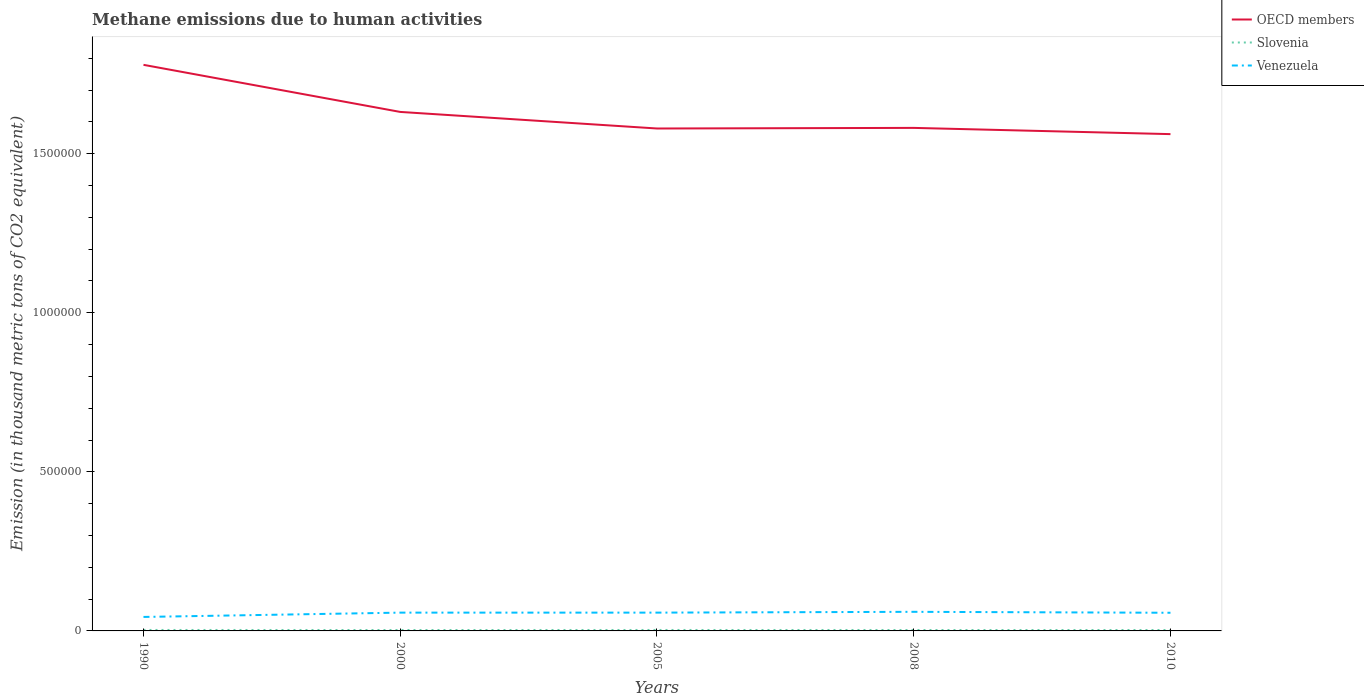Across all years, what is the maximum amount of methane emitted in Venezuela?
Provide a succinct answer. 4.39e+04. In which year was the amount of methane emitted in OECD members maximum?
Your answer should be compact. 2010. What is the total amount of methane emitted in OECD members in the graph?
Give a very brief answer. 1.77e+04. What is the difference between the highest and the second highest amount of methane emitted in OECD members?
Offer a very short reply. 2.18e+05. What is the difference between the highest and the lowest amount of methane emitted in OECD members?
Ensure brevity in your answer.  2. Is the amount of methane emitted in Slovenia strictly greater than the amount of methane emitted in OECD members over the years?
Offer a terse response. Yes. How many years are there in the graph?
Offer a terse response. 5. Are the values on the major ticks of Y-axis written in scientific E-notation?
Provide a short and direct response. No. Does the graph contain any zero values?
Give a very brief answer. No. Does the graph contain grids?
Your response must be concise. No. How many legend labels are there?
Provide a succinct answer. 3. What is the title of the graph?
Provide a succinct answer. Methane emissions due to human activities. Does "Least developed countries" appear as one of the legend labels in the graph?
Provide a short and direct response. No. What is the label or title of the Y-axis?
Ensure brevity in your answer.  Emission (in thousand metric tons of CO2 equivalent). What is the Emission (in thousand metric tons of CO2 equivalent) of OECD members in 1990?
Make the answer very short. 1.78e+06. What is the Emission (in thousand metric tons of CO2 equivalent) in Slovenia in 1990?
Keep it short and to the point. 3033.9. What is the Emission (in thousand metric tons of CO2 equivalent) in Venezuela in 1990?
Make the answer very short. 4.39e+04. What is the Emission (in thousand metric tons of CO2 equivalent) of OECD members in 2000?
Give a very brief answer. 1.63e+06. What is the Emission (in thousand metric tons of CO2 equivalent) in Slovenia in 2000?
Your answer should be very brief. 2871.1. What is the Emission (in thousand metric tons of CO2 equivalent) in Venezuela in 2000?
Provide a succinct answer. 5.75e+04. What is the Emission (in thousand metric tons of CO2 equivalent) of OECD members in 2005?
Offer a terse response. 1.58e+06. What is the Emission (in thousand metric tons of CO2 equivalent) of Slovenia in 2005?
Your answer should be compact. 2979.9. What is the Emission (in thousand metric tons of CO2 equivalent) of Venezuela in 2005?
Give a very brief answer. 5.75e+04. What is the Emission (in thousand metric tons of CO2 equivalent) in OECD members in 2008?
Make the answer very short. 1.58e+06. What is the Emission (in thousand metric tons of CO2 equivalent) in Slovenia in 2008?
Your response must be concise. 2912.5. What is the Emission (in thousand metric tons of CO2 equivalent) in Venezuela in 2008?
Your answer should be compact. 6.00e+04. What is the Emission (in thousand metric tons of CO2 equivalent) in OECD members in 2010?
Offer a terse response. 1.56e+06. What is the Emission (in thousand metric tons of CO2 equivalent) of Slovenia in 2010?
Your answer should be very brief. 2901.7. What is the Emission (in thousand metric tons of CO2 equivalent) of Venezuela in 2010?
Make the answer very short. 5.71e+04. Across all years, what is the maximum Emission (in thousand metric tons of CO2 equivalent) of OECD members?
Provide a short and direct response. 1.78e+06. Across all years, what is the maximum Emission (in thousand metric tons of CO2 equivalent) in Slovenia?
Provide a short and direct response. 3033.9. Across all years, what is the maximum Emission (in thousand metric tons of CO2 equivalent) of Venezuela?
Give a very brief answer. 6.00e+04. Across all years, what is the minimum Emission (in thousand metric tons of CO2 equivalent) of OECD members?
Offer a terse response. 1.56e+06. Across all years, what is the minimum Emission (in thousand metric tons of CO2 equivalent) in Slovenia?
Your response must be concise. 2871.1. Across all years, what is the minimum Emission (in thousand metric tons of CO2 equivalent) in Venezuela?
Keep it short and to the point. 4.39e+04. What is the total Emission (in thousand metric tons of CO2 equivalent) of OECD members in the graph?
Offer a very short reply. 8.13e+06. What is the total Emission (in thousand metric tons of CO2 equivalent) in Slovenia in the graph?
Give a very brief answer. 1.47e+04. What is the total Emission (in thousand metric tons of CO2 equivalent) in Venezuela in the graph?
Provide a short and direct response. 2.76e+05. What is the difference between the Emission (in thousand metric tons of CO2 equivalent) in OECD members in 1990 and that in 2000?
Your response must be concise. 1.48e+05. What is the difference between the Emission (in thousand metric tons of CO2 equivalent) of Slovenia in 1990 and that in 2000?
Offer a terse response. 162.8. What is the difference between the Emission (in thousand metric tons of CO2 equivalent) in Venezuela in 1990 and that in 2000?
Offer a terse response. -1.36e+04. What is the difference between the Emission (in thousand metric tons of CO2 equivalent) of OECD members in 1990 and that in 2005?
Provide a short and direct response. 2.00e+05. What is the difference between the Emission (in thousand metric tons of CO2 equivalent) in Slovenia in 1990 and that in 2005?
Provide a short and direct response. 54. What is the difference between the Emission (in thousand metric tons of CO2 equivalent) in Venezuela in 1990 and that in 2005?
Give a very brief answer. -1.36e+04. What is the difference between the Emission (in thousand metric tons of CO2 equivalent) in OECD members in 1990 and that in 2008?
Your answer should be compact. 1.98e+05. What is the difference between the Emission (in thousand metric tons of CO2 equivalent) in Slovenia in 1990 and that in 2008?
Provide a short and direct response. 121.4. What is the difference between the Emission (in thousand metric tons of CO2 equivalent) in Venezuela in 1990 and that in 2008?
Provide a short and direct response. -1.61e+04. What is the difference between the Emission (in thousand metric tons of CO2 equivalent) of OECD members in 1990 and that in 2010?
Offer a terse response. 2.18e+05. What is the difference between the Emission (in thousand metric tons of CO2 equivalent) in Slovenia in 1990 and that in 2010?
Provide a succinct answer. 132.2. What is the difference between the Emission (in thousand metric tons of CO2 equivalent) in Venezuela in 1990 and that in 2010?
Ensure brevity in your answer.  -1.31e+04. What is the difference between the Emission (in thousand metric tons of CO2 equivalent) in OECD members in 2000 and that in 2005?
Make the answer very short. 5.21e+04. What is the difference between the Emission (in thousand metric tons of CO2 equivalent) in Slovenia in 2000 and that in 2005?
Offer a very short reply. -108.8. What is the difference between the Emission (in thousand metric tons of CO2 equivalent) of OECD members in 2000 and that in 2008?
Offer a terse response. 5.02e+04. What is the difference between the Emission (in thousand metric tons of CO2 equivalent) in Slovenia in 2000 and that in 2008?
Keep it short and to the point. -41.4. What is the difference between the Emission (in thousand metric tons of CO2 equivalent) of Venezuela in 2000 and that in 2008?
Keep it short and to the point. -2550.4. What is the difference between the Emission (in thousand metric tons of CO2 equivalent) of OECD members in 2000 and that in 2010?
Provide a short and direct response. 6.98e+04. What is the difference between the Emission (in thousand metric tons of CO2 equivalent) of Slovenia in 2000 and that in 2010?
Your answer should be very brief. -30.6. What is the difference between the Emission (in thousand metric tons of CO2 equivalent) in Venezuela in 2000 and that in 2010?
Offer a very short reply. 425.9. What is the difference between the Emission (in thousand metric tons of CO2 equivalent) of OECD members in 2005 and that in 2008?
Your response must be concise. -1871.6. What is the difference between the Emission (in thousand metric tons of CO2 equivalent) in Slovenia in 2005 and that in 2008?
Keep it short and to the point. 67.4. What is the difference between the Emission (in thousand metric tons of CO2 equivalent) in Venezuela in 2005 and that in 2008?
Offer a terse response. -2551.2. What is the difference between the Emission (in thousand metric tons of CO2 equivalent) of OECD members in 2005 and that in 2010?
Your response must be concise. 1.77e+04. What is the difference between the Emission (in thousand metric tons of CO2 equivalent) of Slovenia in 2005 and that in 2010?
Offer a very short reply. 78.2. What is the difference between the Emission (in thousand metric tons of CO2 equivalent) of Venezuela in 2005 and that in 2010?
Make the answer very short. 425.1. What is the difference between the Emission (in thousand metric tons of CO2 equivalent) of OECD members in 2008 and that in 2010?
Provide a succinct answer. 1.96e+04. What is the difference between the Emission (in thousand metric tons of CO2 equivalent) of Venezuela in 2008 and that in 2010?
Provide a short and direct response. 2976.3. What is the difference between the Emission (in thousand metric tons of CO2 equivalent) in OECD members in 1990 and the Emission (in thousand metric tons of CO2 equivalent) in Slovenia in 2000?
Give a very brief answer. 1.78e+06. What is the difference between the Emission (in thousand metric tons of CO2 equivalent) of OECD members in 1990 and the Emission (in thousand metric tons of CO2 equivalent) of Venezuela in 2000?
Provide a succinct answer. 1.72e+06. What is the difference between the Emission (in thousand metric tons of CO2 equivalent) of Slovenia in 1990 and the Emission (in thousand metric tons of CO2 equivalent) of Venezuela in 2000?
Ensure brevity in your answer.  -5.45e+04. What is the difference between the Emission (in thousand metric tons of CO2 equivalent) in OECD members in 1990 and the Emission (in thousand metric tons of CO2 equivalent) in Slovenia in 2005?
Make the answer very short. 1.78e+06. What is the difference between the Emission (in thousand metric tons of CO2 equivalent) of OECD members in 1990 and the Emission (in thousand metric tons of CO2 equivalent) of Venezuela in 2005?
Your response must be concise. 1.72e+06. What is the difference between the Emission (in thousand metric tons of CO2 equivalent) in Slovenia in 1990 and the Emission (in thousand metric tons of CO2 equivalent) in Venezuela in 2005?
Provide a short and direct response. -5.45e+04. What is the difference between the Emission (in thousand metric tons of CO2 equivalent) of OECD members in 1990 and the Emission (in thousand metric tons of CO2 equivalent) of Slovenia in 2008?
Provide a succinct answer. 1.78e+06. What is the difference between the Emission (in thousand metric tons of CO2 equivalent) of OECD members in 1990 and the Emission (in thousand metric tons of CO2 equivalent) of Venezuela in 2008?
Your answer should be very brief. 1.72e+06. What is the difference between the Emission (in thousand metric tons of CO2 equivalent) of Slovenia in 1990 and the Emission (in thousand metric tons of CO2 equivalent) of Venezuela in 2008?
Your answer should be very brief. -5.70e+04. What is the difference between the Emission (in thousand metric tons of CO2 equivalent) of OECD members in 1990 and the Emission (in thousand metric tons of CO2 equivalent) of Slovenia in 2010?
Offer a terse response. 1.78e+06. What is the difference between the Emission (in thousand metric tons of CO2 equivalent) of OECD members in 1990 and the Emission (in thousand metric tons of CO2 equivalent) of Venezuela in 2010?
Provide a succinct answer. 1.72e+06. What is the difference between the Emission (in thousand metric tons of CO2 equivalent) in Slovenia in 1990 and the Emission (in thousand metric tons of CO2 equivalent) in Venezuela in 2010?
Your answer should be very brief. -5.40e+04. What is the difference between the Emission (in thousand metric tons of CO2 equivalent) of OECD members in 2000 and the Emission (in thousand metric tons of CO2 equivalent) of Slovenia in 2005?
Make the answer very short. 1.63e+06. What is the difference between the Emission (in thousand metric tons of CO2 equivalent) of OECD members in 2000 and the Emission (in thousand metric tons of CO2 equivalent) of Venezuela in 2005?
Your answer should be very brief. 1.57e+06. What is the difference between the Emission (in thousand metric tons of CO2 equivalent) of Slovenia in 2000 and the Emission (in thousand metric tons of CO2 equivalent) of Venezuela in 2005?
Give a very brief answer. -5.46e+04. What is the difference between the Emission (in thousand metric tons of CO2 equivalent) in OECD members in 2000 and the Emission (in thousand metric tons of CO2 equivalent) in Slovenia in 2008?
Make the answer very short. 1.63e+06. What is the difference between the Emission (in thousand metric tons of CO2 equivalent) in OECD members in 2000 and the Emission (in thousand metric tons of CO2 equivalent) in Venezuela in 2008?
Provide a succinct answer. 1.57e+06. What is the difference between the Emission (in thousand metric tons of CO2 equivalent) in Slovenia in 2000 and the Emission (in thousand metric tons of CO2 equivalent) in Venezuela in 2008?
Ensure brevity in your answer.  -5.72e+04. What is the difference between the Emission (in thousand metric tons of CO2 equivalent) in OECD members in 2000 and the Emission (in thousand metric tons of CO2 equivalent) in Slovenia in 2010?
Make the answer very short. 1.63e+06. What is the difference between the Emission (in thousand metric tons of CO2 equivalent) in OECD members in 2000 and the Emission (in thousand metric tons of CO2 equivalent) in Venezuela in 2010?
Provide a short and direct response. 1.57e+06. What is the difference between the Emission (in thousand metric tons of CO2 equivalent) of Slovenia in 2000 and the Emission (in thousand metric tons of CO2 equivalent) of Venezuela in 2010?
Give a very brief answer. -5.42e+04. What is the difference between the Emission (in thousand metric tons of CO2 equivalent) in OECD members in 2005 and the Emission (in thousand metric tons of CO2 equivalent) in Slovenia in 2008?
Your answer should be compact. 1.58e+06. What is the difference between the Emission (in thousand metric tons of CO2 equivalent) in OECD members in 2005 and the Emission (in thousand metric tons of CO2 equivalent) in Venezuela in 2008?
Provide a short and direct response. 1.52e+06. What is the difference between the Emission (in thousand metric tons of CO2 equivalent) in Slovenia in 2005 and the Emission (in thousand metric tons of CO2 equivalent) in Venezuela in 2008?
Provide a short and direct response. -5.71e+04. What is the difference between the Emission (in thousand metric tons of CO2 equivalent) of OECD members in 2005 and the Emission (in thousand metric tons of CO2 equivalent) of Slovenia in 2010?
Offer a very short reply. 1.58e+06. What is the difference between the Emission (in thousand metric tons of CO2 equivalent) in OECD members in 2005 and the Emission (in thousand metric tons of CO2 equivalent) in Venezuela in 2010?
Your response must be concise. 1.52e+06. What is the difference between the Emission (in thousand metric tons of CO2 equivalent) in Slovenia in 2005 and the Emission (in thousand metric tons of CO2 equivalent) in Venezuela in 2010?
Make the answer very short. -5.41e+04. What is the difference between the Emission (in thousand metric tons of CO2 equivalent) of OECD members in 2008 and the Emission (in thousand metric tons of CO2 equivalent) of Slovenia in 2010?
Keep it short and to the point. 1.58e+06. What is the difference between the Emission (in thousand metric tons of CO2 equivalent) in OECD members in 2008 and the Emission (in thousand metric tons of CO2 equivalent) in Venezuela in 2010?
Provide a succinct answer. 1.52e+06. What is the difference between the Emission (in thousand metric tons of CO2 equivalent) in Slovenia in 2008 and the Emission (in thousand metric tons of CO2 equivalent) in Venezuela in 2010?
Provide a succinct answer. -5.42e+04. What is the average Emission (in thousand metric tons of CO2 equivalent) of OECD members per year?
Your answer should be very brief. 1.63e+06. What is the average Emission (in thousand metric tons of CO2 equivalent) of Slovenia per year?
Keep it short and to the point. 2939.82. What is the average Emission (in thousand metric tons of CO2 equivalent) of Venezuela per year?
Make the answer very short. 5.52e+04. In the year 1990, what is the difference between the Emission (in thousand metric tons of CO2 equivalent) of OECD members and Emission (in thousand metric tons of CO2 equivalent) of Slovenia?
Offer a terse response. 1.78e+06. In the year 1990, what is the difference between the Emission (in thousand metric tons of CO2 equivalent) of OECD members and Emission (in thousand metric tons of CO2 equivalent) of Venezuela?
Make the answer very short. 1.74e+06. In the year 1990, what is the difference between the Emission (in thousand metric tons of CO2 equivalent) of Slovenia and Emission (in thousand metric tons of CO2 equivalent) of Venezuela?
Offer a terse response. -4.09e+04. In the year 2000, what is the difference between the Emission (in thousand metric tons of CO2 equivalent) of OECD members and Emission (in thousand metric tons of CO2 equivalent) of Slovenia?
Offer a terse response. 1.63e+06. In the year 2000, what is the difference between the Emission (in thousand metric tons of CO2 equivalent) of OECD members and Emission (in thousand metric tons of CO2 equivalent) of Venezuela?
Your response must be concise. 1.57e+06. In the year 2000, what is the difference between the Emission (in thousand metric tons of CO2 equivalent) of Slovenia and Emission (in thousand metric tons of CO2 equivalent) of Venezuela?
Provide a succinct answer. -5.46e+04. In the year 2005, what is the difference between the Emission (in thousand metric tons of CO2 equivalent) in OECD members and Emission (in thousand metric tons of CO2 equivalent) in Slovenia?
Provide a short and direct response. 1.58e+06. In the year 2005, what is the difference between the Emission (in thousand metric tons of CO2 equivalent) in OECD members and Emission (in thousand metric tons of CO2 equivalent) in Venezuela?
Give a very brief answer. 1.52e+06. In the year 2005, what is the difference between the Emission (in thousand metric tons of CO2 equivalent) of Slovenia and Emission (in thousand metric tons of CO2 equivalent) of Venezuela?
Keep it short and to the point. -5.45e+04. In the year 2008, what is the difference between the Emission (in thousand metric tons of CO2 equivalent) in OECD members and Emission (in thousand metric tons of CO2 equivalent) in Slovenia?
Provide a short and direct response. 1.58e+06. In the year 2008, what is the difference between the Emission (in thousand metric tons of CO2 equivalent) of OECD members and Emission (in thousand metric tons of CO2 equivalent) of Venezuela?
Offer a very short reply. 1.52e+06. In the year 2008, what is the difference between the Emission (in thousand metric tons of CO2 equivalent) of Slovenia and Emission (in thousand metric tons of CO2 equivalent) of Venezuela?
Make the answer very short. -5.71e+04. In the year 2010, what is the difference between the Emission (in thousand metric tons of CO2 equivalent) in OECD members and Emission (in thousand metric tons of CO2 equivalent) in Slovenia?
Ensure brevity in your answer.  1.56e+06. In the year 2010, what is the difference between the Emission (in thousand metric tons of CO2 equivalent) of OECD members and Emission (in thousand metric tons of CO2 equivalent) of Venezuela?
Offer a terse response. 1.50e+06. In the year 2010, what is the difference between the Emission (in thousand metric tons of CO2 equivalent) in Slovenia and Emission (in thousand metric tons of CO2 equivalent) in Venezuela?
Keep it short and to the point. -5.42e+04. What is the ratio of the Emission (in thousand metric tons of CO2 equivalent) in OECD members in 1990 to that in 2000?
Give a very brief answer. 1.09. What is the ratio of the Emission (in thousand metric tons of CO2 equivalent) of Slovenia in 1990 to that in 2000?
Make the answer very short. 1.06. What is the ratio of the Emission (in thousand metric tons of CO2 equivalent) of Venezuela in 1990 to that in 2000?
Keep it short and to the point. 0.76. What is the ratio of the Emission (in thousand metric tons of CO2 equivalent) of OECD members in 1990 to that in 2005?
Keep it short and to the point. 1.13. What is the ratio of the Emission (in thousand metric tons of CO2 equivalent) in Slovenia in 1990 to that in 2005?
Make the answer very short. 1.02. What is the ratio of the Emission (in thousand metric tons of CO2 equivalent) in Venezuela in 1990 to that in 2005?
Offer a very short reply. 0.76. What is the ratio of the Emission (in thousand metric tons of CO2 equivalent) of OECD members in 1990 to that in 2008?
Give a very brief answer. 1.13. What is the ratio of the Emission (in thousand metric tons of CO2 equivalent) in Slovenia in 1990 to that in 2008?
Offer a terse response. 1.04. What is the ratio of the Emission (in thousand metric tons of CO2 equivalent) of Venezuela in 1990 to that in 2008?
Provide a succinct answer. 0.73. What is the ratio of the Emission (in thousand metric tons of CO2 equivalent) in OECD members in 1990 to that in 2010?
Provide a succinct answer. 1.14. What is the ratio of the Emission (in thousand metric tons of CO2 equivalent) in Slovenia in 1990 to that in 2010?
Your answer should be compact. 1.05. What is the ratio of the Emission (in thousand metric tons of CO2 equivalent) in Venezuela in 1990 to that in 2010?
Ensure brevity in your answer.  0.77. What is the ratio of the Emission (in thousand metric tons of CO2 equivalent) of OECD members in 2000 to that in 2005?
Keep it short and to the point. 1.03. What is the ratio of the Emission (in thousand metric tons of CO2 equivalent) in Slovenia in 2000 to that in 2005?
Your answer should be compact. 0.96. What is the ratio of the Emission (in thousand metric tons of CO2 equivalent) of OECD members in 2000 to that in 2008?
Your answer should be very brief. 1.03. What is the ratio of the Emission (in thousand metric tons of CO2 equivalent) of Slovenia in 2000 to that in 2008?
Your response must be concise. 0.99. What is the ratio of the Emission (in thousand metric tons of CO2 equivalent) in Venezuela in 2000 to that in 2008?
Give a very brief answer. 0.96. What is the ratio of the Emission (in thousand metric tons of CO2 equivalent) of OECD members in 2000 to that in 2010?
Your response must be concise. 1.04. What is the ratio of the Emission (in thousand metric tons of CO2 equivalent) in Slovenia in 2000 to that in 2010?
Keep it short and to the point. 0.99. What is the ratio of the Emission (in thousand metric tons of CO2 equivalent) in Venezuela in 2000 to that in 2010?
Provide a succinct answer. 1.01. What is the ratio of the Emission (in thousand metric tons of CO2 equivalent) in Slovenia in 2005 to that in 2008?
Provide a succinct answer. 1.02. What is the ratio of the Emission (in thousand metric tons of CO2 equivalent) in Venezuela in 2005 to that in 2008?
Your answer should be compact. 0.96. What is the ratio of the Emission (in thousand metric tons of CO2 equivalent) in OECD members in 2005 to that in 2010?
Offer a very short reply. 1.01. What is the ratio of the Emission (in thousand metric tons of CO2 equivalent) in Slovenia in 2005 to that in 2010?
Give a very brief answer. 1.03. What is the ratio of the Emission (in thousand metric tons of CO2 equivalent) of Venezuela in 2005 to that in 2010?
Offer a terse response. 1.01. What is the ratio of the Emission (in thousand metric tons of CO2 equivalent) in OECD members in 2008 to that in 2010?
Give a very brief answer. 1.01. What is the ratio of the Emission (in thousand metric tons of CO2 equivalent) in Slovenia in 2008 to that in 2010?
Ensure brevity in your answer.  1. What is the ratio of the Emission (in thousand metric tons of CO2 equivalent) of Venezuela in 2008 to that in 2010?
Ensure brevity in your answer.  1.05. What is the difference between the highest and the second highest Emission (in thousand metric tons of CO2 equivalent) of OECD members?
Provide a short and direct response. 1.48e+05. What is the difference between the highest and the second highest Emission (in thousand metric tons of CO2 equivalent) in Slovenia?
Offer a very short reply. 54. What is the difference between the highest and the second highest Emission (in thousand metric tons of CO2 equivalent) in Venezuela?
Offer a terse response. 2550.4. What is the difference between the highest and the lowest Emission (in thousand metric tons of CO2 equivalent) in OECD members?
Provide a short and direct response. 2.18e+05. What is the difference between the highest and the lowest Emission (in thousand metric tons of CO2 equivalent) in Slovenia?
Ensure brevity in your answer.  162.8. What is the difference between the highest and the lowest Emission (in thousand metric tons of CO2 equivalent) of Venezuela?
Your response must be concise. 1.61e+04. 